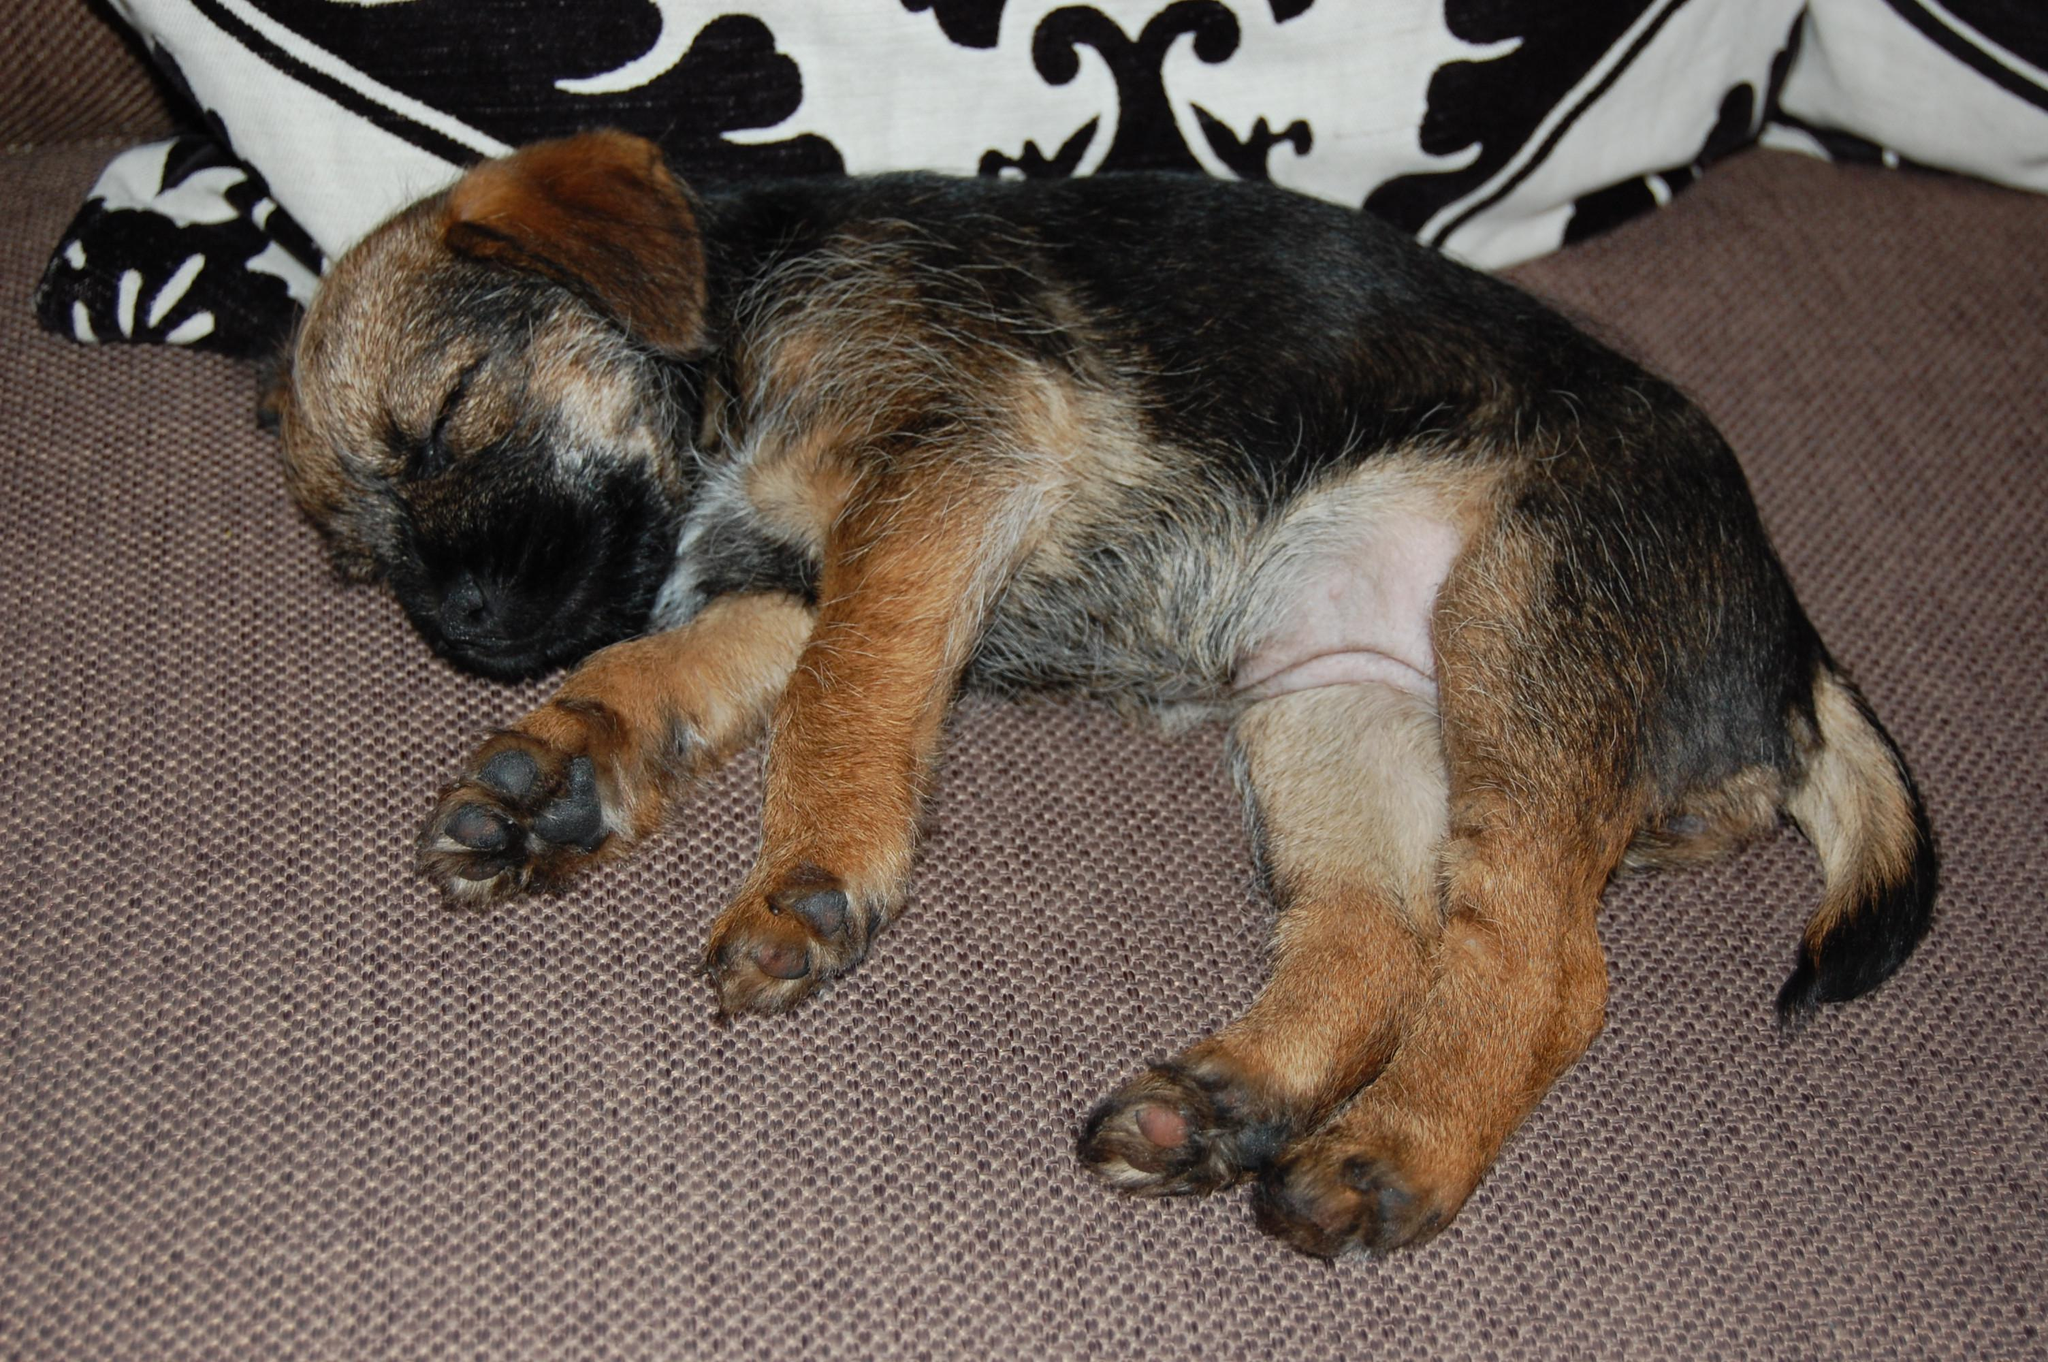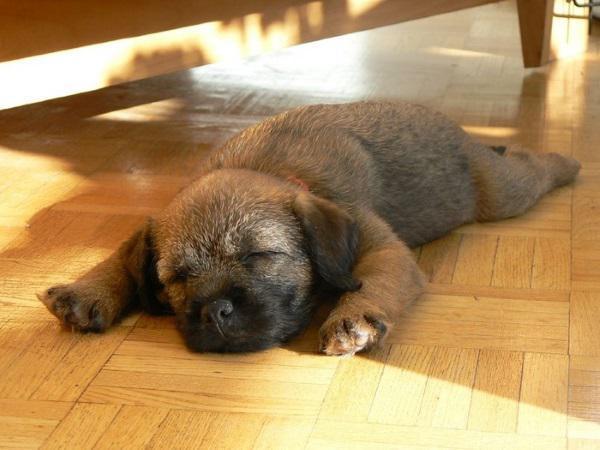The first image is the image on the left, the second image is the image on the right. Examine the images to the left and right. Is the description "One image shows two dogs snoozing together." accurate? Answer yes or no. No. The first image is the image on the left, the second image is the image on the right. Evaluate the accuracy of this statement regarding the images: "There are three dogs sleeping". Is it true? Answer yes or no. No. 